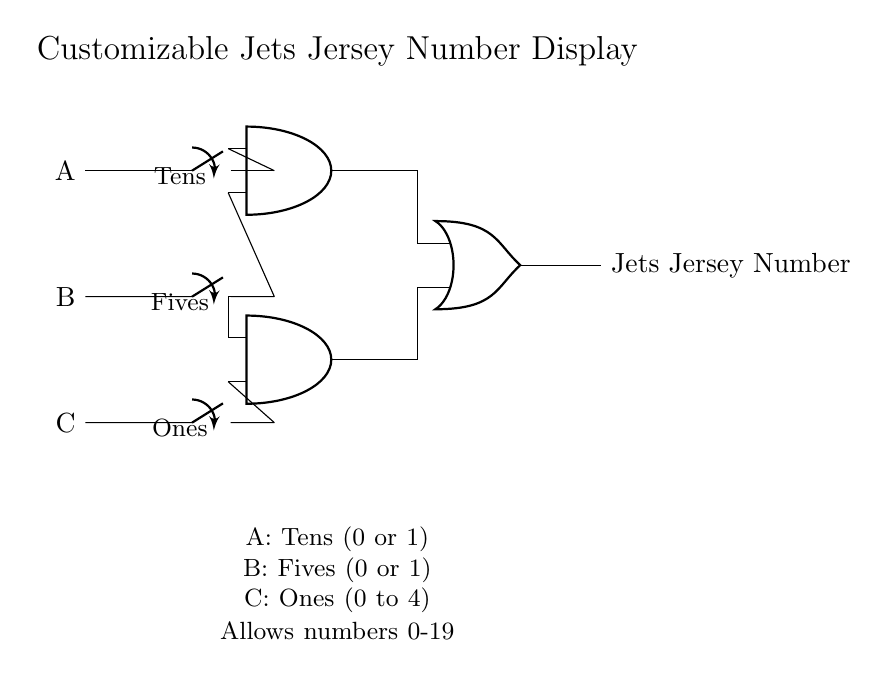What are the input switches labeled in the circuit? The circuit has three input switches labeled A, B, and C. A represents the tens place, B represents the fives place, and C represents the ones place.
Answer: A, B, C How many AND gates are present in the circuit? The circuit includes two AND gates, both of which are used to combine the inputs in order to determine part of the jersey number display's output.
Answer: 2 What does the output of the OR gate represent? The output of the OR gate represents the final Jets jersey number displayed, derived from the inputs processed by the AND gates.
Answer: Jets Jersey Number What are the possible values for input C? Input C can take values from zero to four, which corresponds to the ones place for the jersey number display.
Answer: 0 to 4 Which logic gates contribute to the final output? The AND gates feed into the OR gate to produce the final output for the jersey number display, making both types of gates essential in the logic design.
Answer: AND gates and OR gate How is input A utilized in the circuit? Input A is utilized in the first AND gate to determine the contribution of the tens place to the final output based on the overall logic operation.
Answer: Tens place 